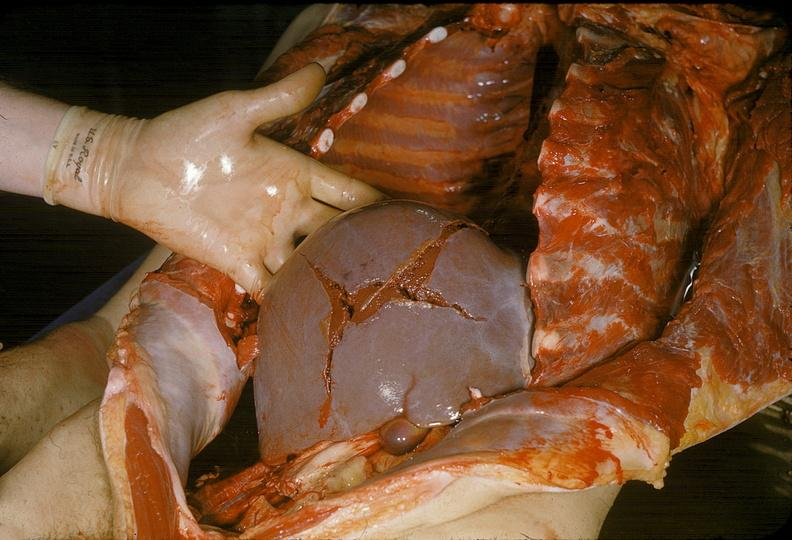where is this area in the body?
Answer the question using a single word or phrase. Abdomen 